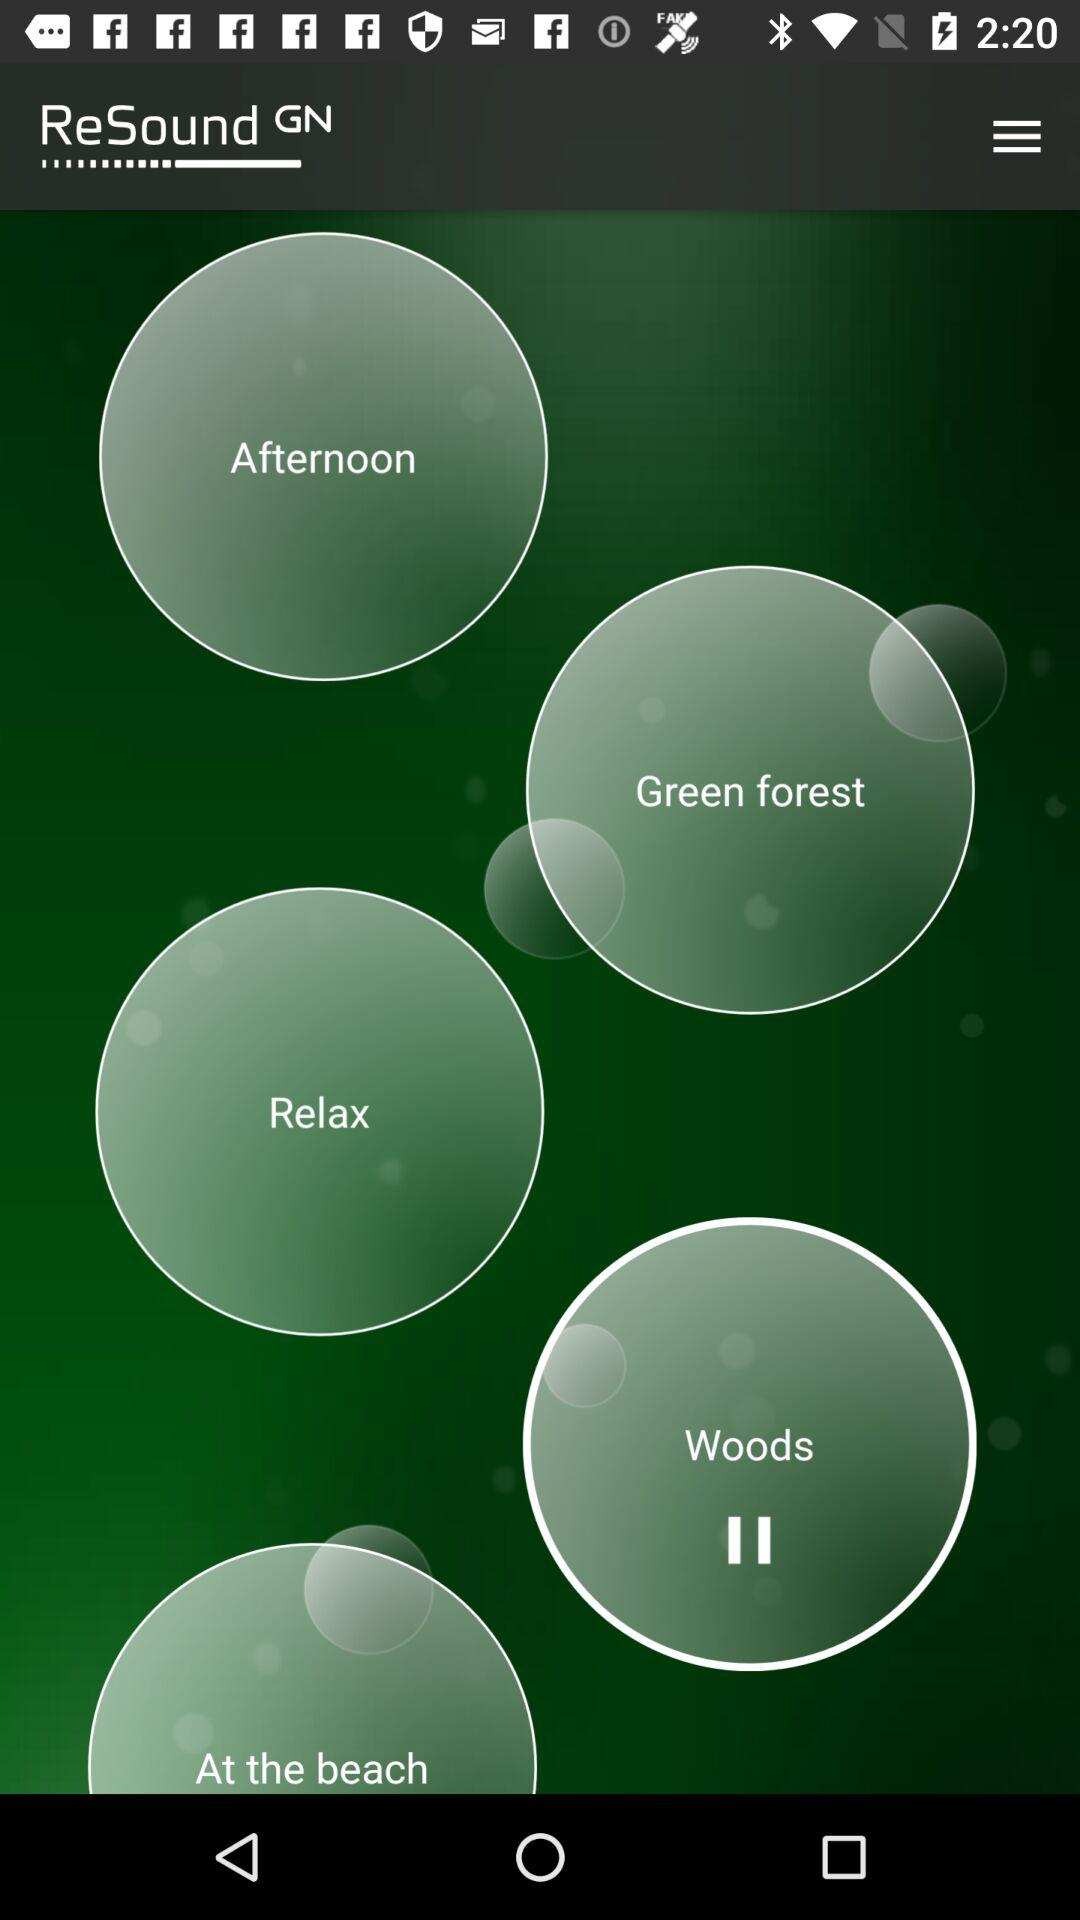What is the application name? The application name is "ReSound". 